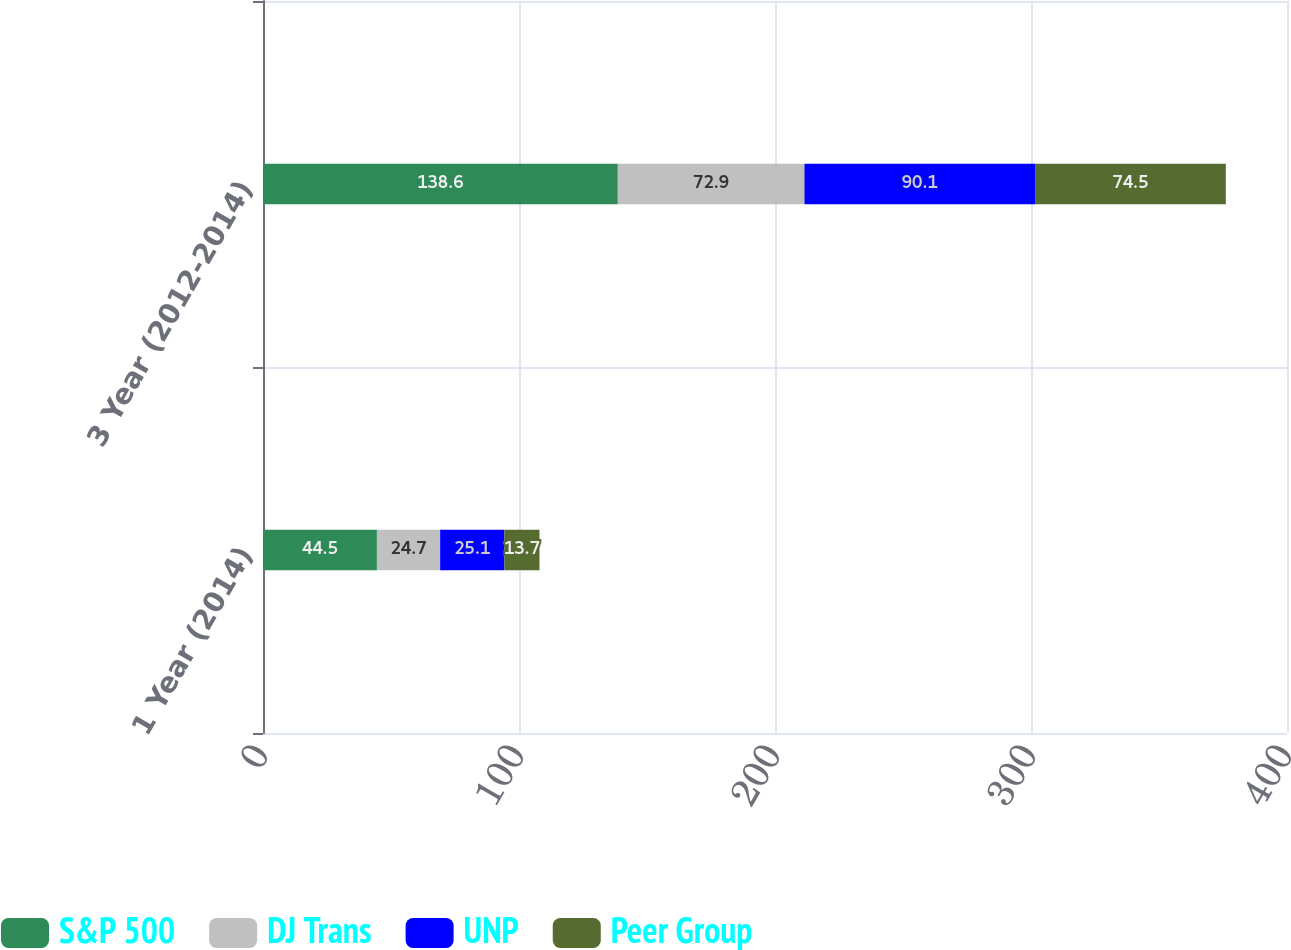Convert chart. <chart><loc_0><loc_0><loc_500><loc_500><stacked_bar_chart><ecel><fcel>1 Year (2014)<fcel>3 Year (2012-2014)<nl><fcel>S&P 500<fcel>44.5<fcel>138.6<nl><fcel>DJ Trans<fcel>24.7<fcel>72.9<nl><fcel>UNP<fcel>25.1<fcel>90.1<nl><fcel>Peer Group<fcel>13.7<fcel>74.5<nl></chart> 